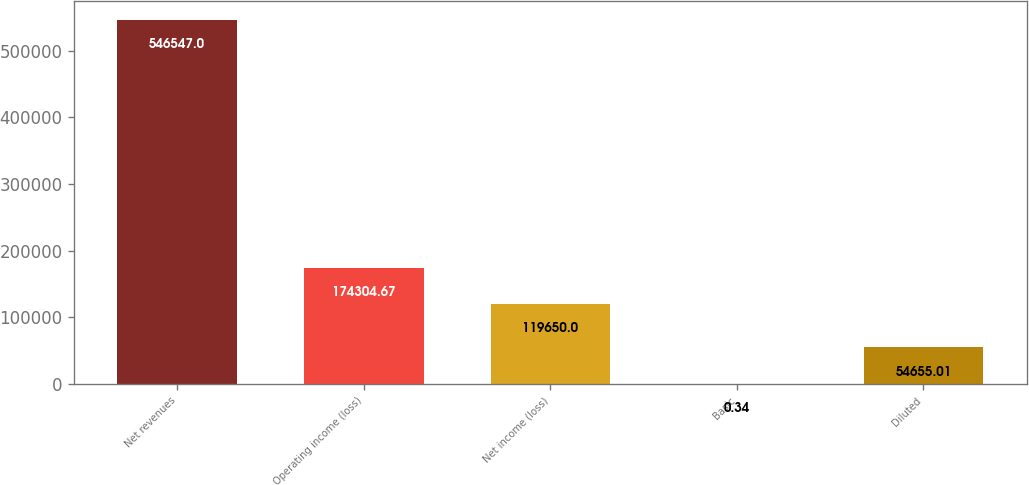<chart> <loc_0><loc_0><loc_500><loc_500><bar_chart><fcel>Net revenues<fcel>Operating income (loss)<fcel>Net income (loss)<fcel>Basic<fcel>Diluted<nl><fcel>546547<fcel>174305<fcel>119650<fcel>0.34<fcel>54655<nl></chart> 